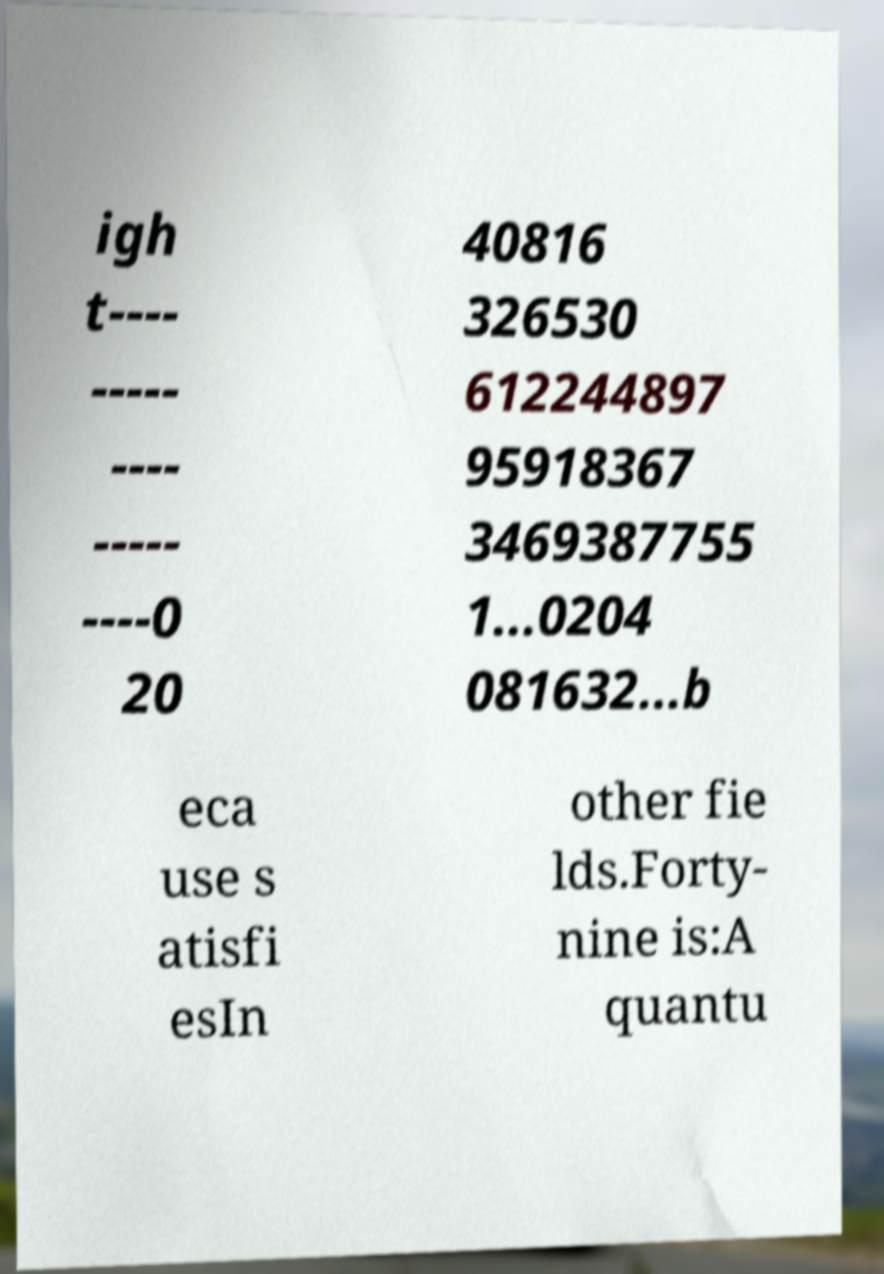Please read and relay the text visible in this image. What does it say? igh t---- ----- ---- ----- ----0 20 40816 326530 612244897 95918367 3469387755 1...0204 081632...b eca use s atisfi esIn other fie lds.Forty- nine is:A quantu 